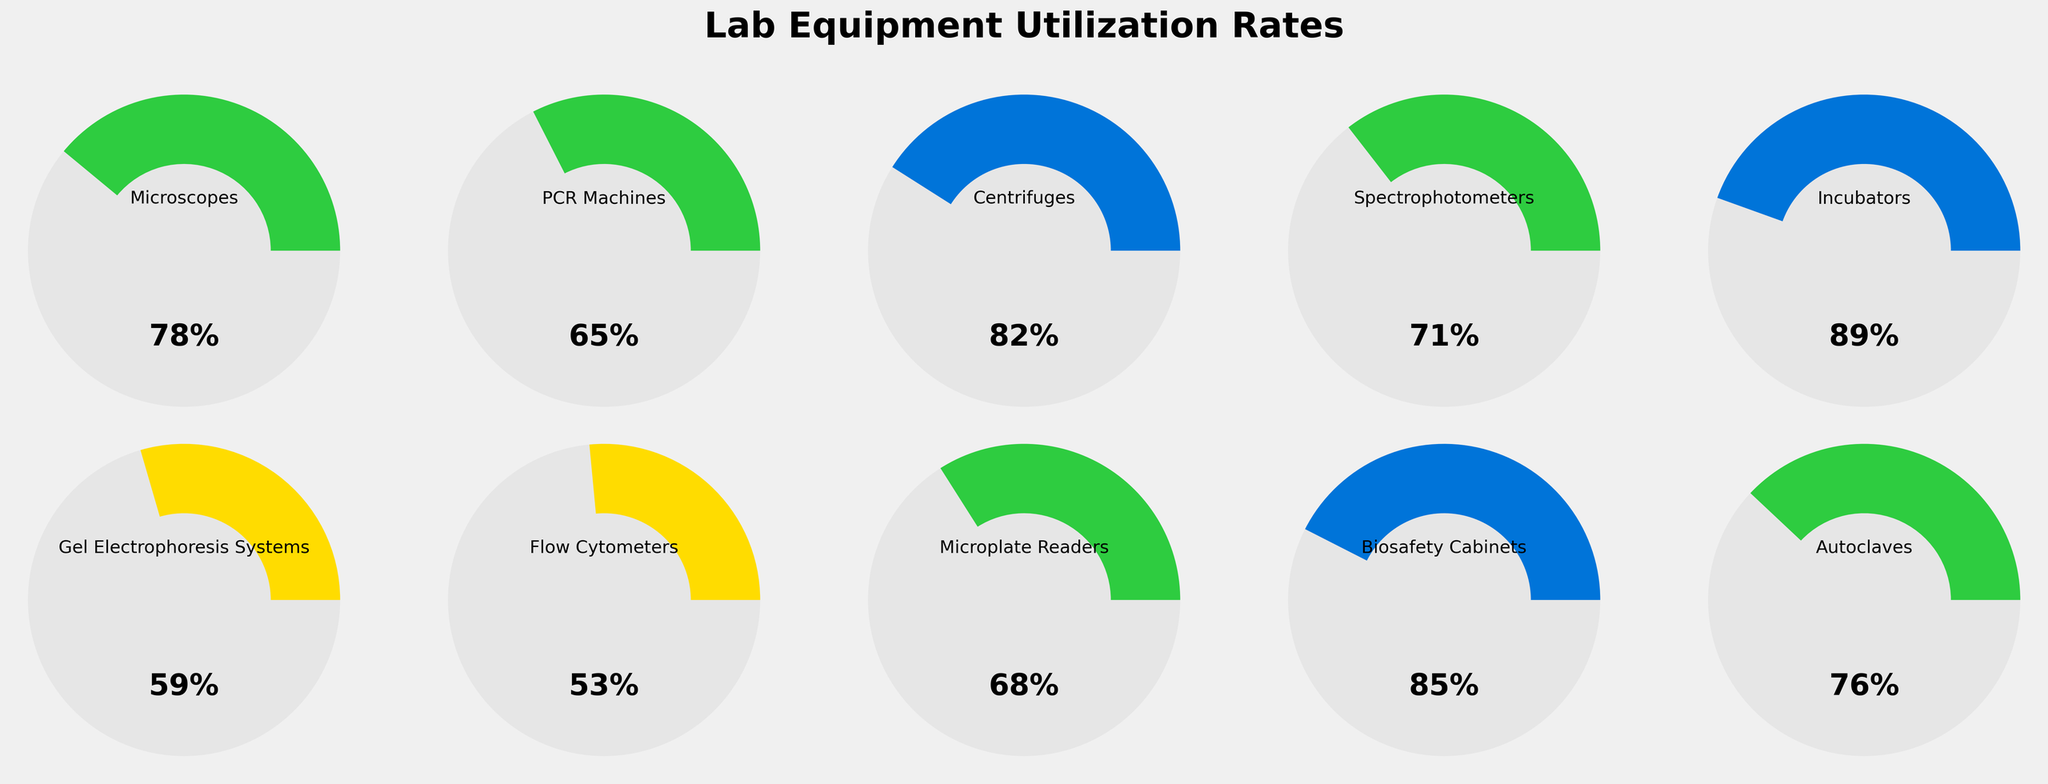How many types of lab equipment are displayed in the figure? The figure shows 10 separate gauges, each representing a different type of lab equipment, as indicated by the labels and the title.
Answer: 10 Which piece of equipment has the highest utilization rate? By examining the wedges and the percentage labels on the gauges, Incubators have the highest utilization rate, indicated by the gauge with the largest filled wedge and the label of 89%.
Answer: Incubators What's the average utilization rate of the Flow Cytometers and Microplate Readers? Look at the utilization rates of Flow Cytometers (53%) and Microplate Readers (68%). Sum these values and divide by 2: (53 + 68) / 2 = 60.5%.
Answer: 60.5% Which equipment has a utilization rate closest to 75%? Scan through the percentages to find the rate nearest to 75%. The Autoclaves have a utilization rate of 76%, which is closest to 75%.
Answer: Autoclaves What's the difference in utilization rate between Gel Electrophoresis Systems and Centrifuges? Locate the rates for Gel Electrophoresis Systems (59%) and Centrifuges (82%). Calculate the difference: 82 - 59 = 23%.
Answer: 23% Which color represents the gauge range for the utilization rate of the Spectrophotometers? Spectrophotometers are shown with a utilization rate of 71%, which falls into the section colored in the mid-range green according to the color-coded ranges.
Answer: green How many pieces of equipment have a utilization rate above 70%? Count the gauges that have utilization rates above 70%: Microscopes (78%), Centrifuges (82%), Spectrophotometers (71%), Incubators (89%), Biosafety Cabinets (85%), and Autoclaves (76%). This gives 6 pieces of equipment.
Answer: 6 Which piece of equipment has the smallest utilization rate and what is its value? The smallest utilization rate can be identified by finding the gauge with the smallest filled wedge. Flow Cytometers have the smallest utilization rate of 53%.
Answer: Flow Cytometers at 53% By how much does the utilization rate of Biosafety Cabinets exceed that of PCR Machines? Look at the utilization rates for Biosafety Cabinets (85%) and PCR Machines (65%). Subtract the smaller rate from the larger one: 85 - 65 = 20%.
Answer: 20% 